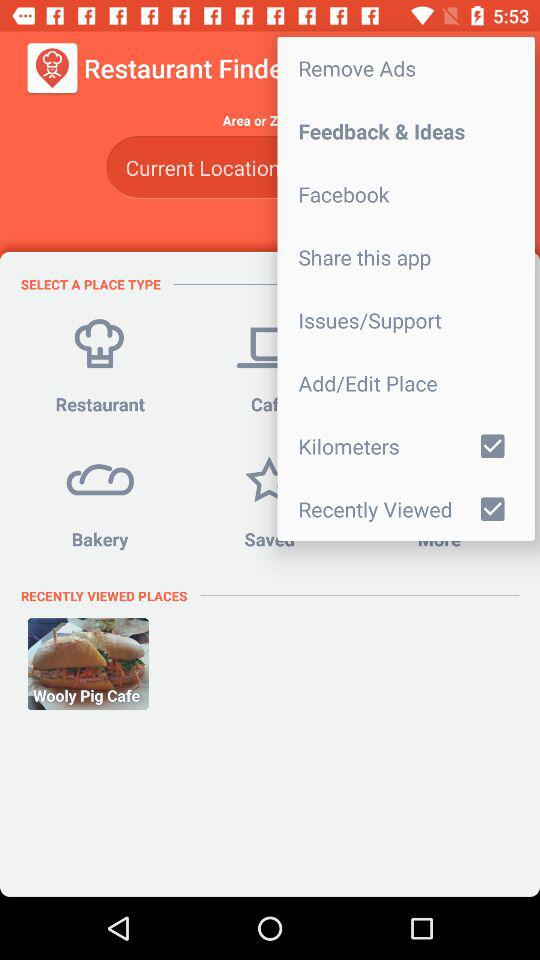What is the status of the "Kilometers"? The status is "on". 